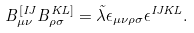Convert formula to latex. <formula><loc_0><loc_0><loc_500><loc_500>B ^ { [ I J } _ { \mu \nu } B ^ { K L ] } _ { \rho \sigma } = \tilde { \lambda } \epsilon _ { \mu \nu \rho \sigma } \epsilon ^ { I J K L } .</formula> 